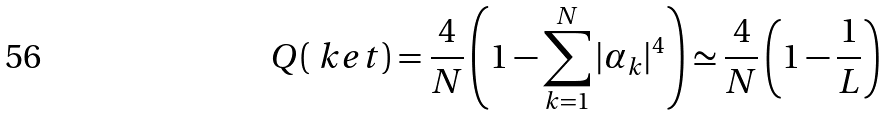Convert formula to latex. <formula><loc_0><loc_0><loc_500><loc_500>Q ( \ k e t ) = \frac { 4 } { N } \left ( 1 - \sum _ { k = 1 } ^ { N } | \alpha _ { k } | ^ { 4 } \right ) \simeq \frac { 4 } { N } \left ( 1 - \frac { 1 } { L } \right )</formula> 